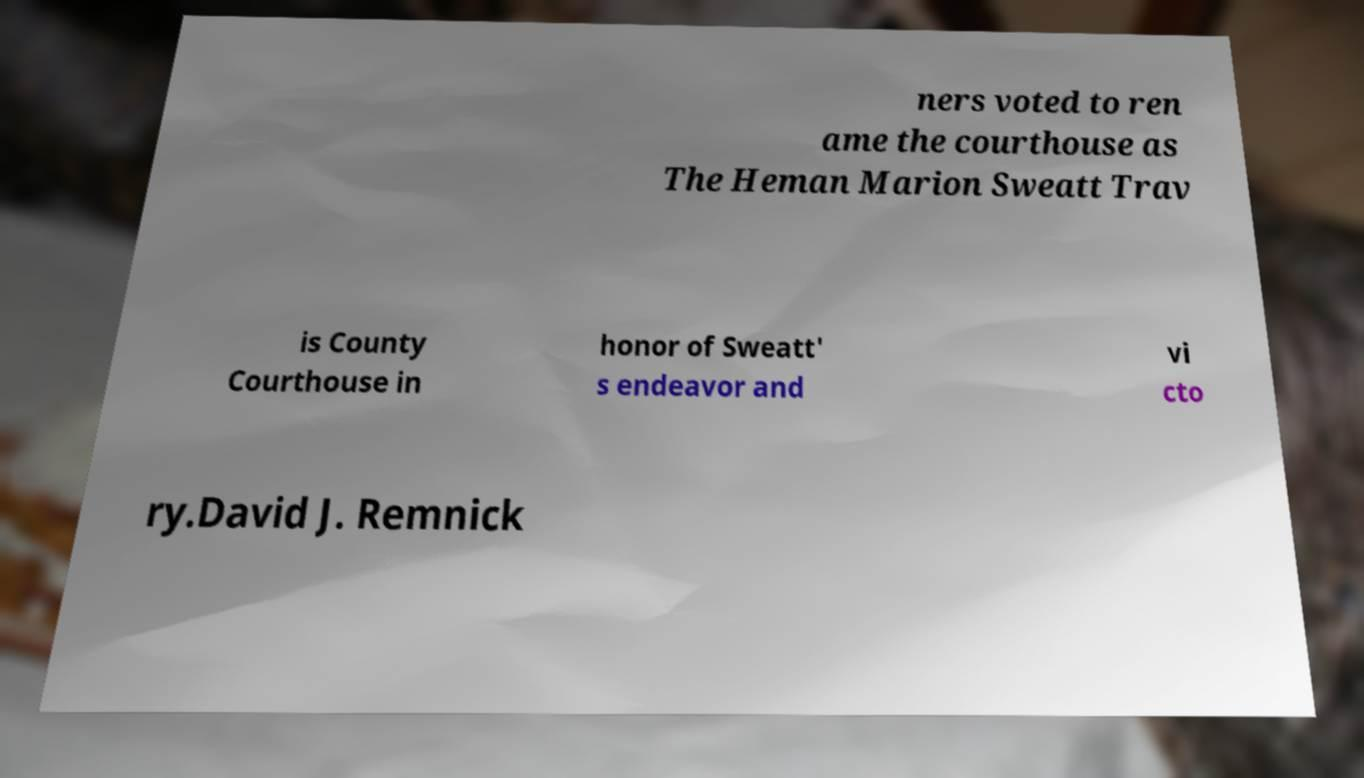Please read and relay the text visible in this image. What does it say? ners voted to ren ame the courthouse as The Heman Marion Sweatt Trav is County Courthouse in honor of Sweatt' s endeavor and vi cto ry.David J. Remnick 